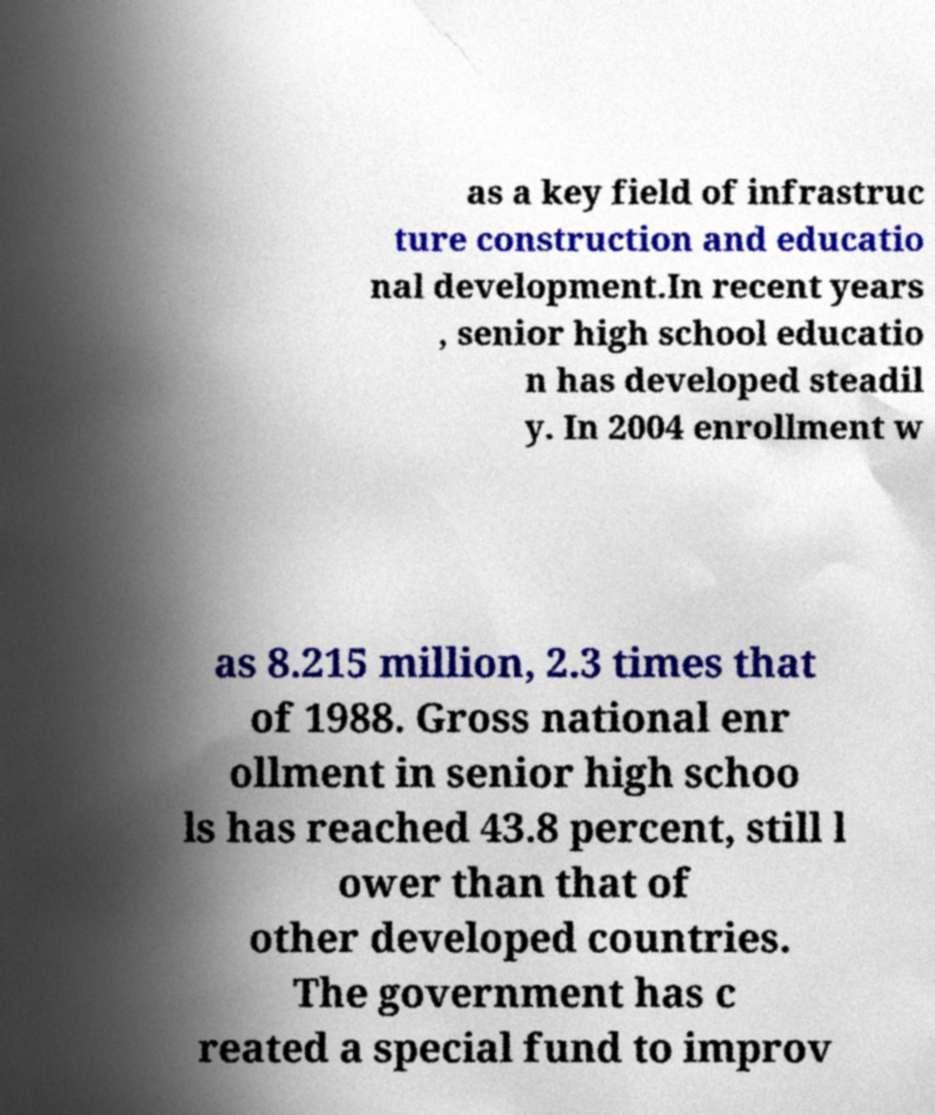Please identify and transcribe the text found in this image. as a key field of infrastruc ture construction and educatio nal development.In recent years , senior high school educatio n has developed steadil y. In 2004 enrollment w as 8.215 million, 2.3 times that of 1988. Gross national enr ollment in senior high schoo ls has reached 43.8 percent, still l ower than that of other developed countries. The government has c reated a special fund to improv 